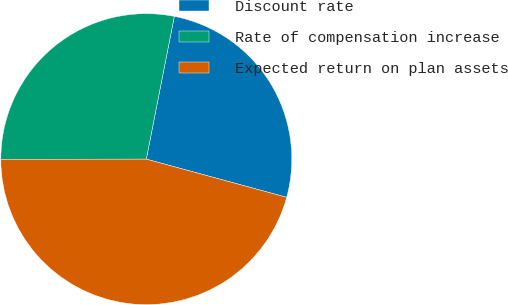Convert chart. <chart><loc_0><loc_0><loc_500><loc_500><pie_chart><fcel>Discount rate<fcel>Rate of compensation increase<fcel>Expected return on plan assets<nl><fcel>26.14%<fcel>28.1%<fcel>45.75%<nl></chart> 